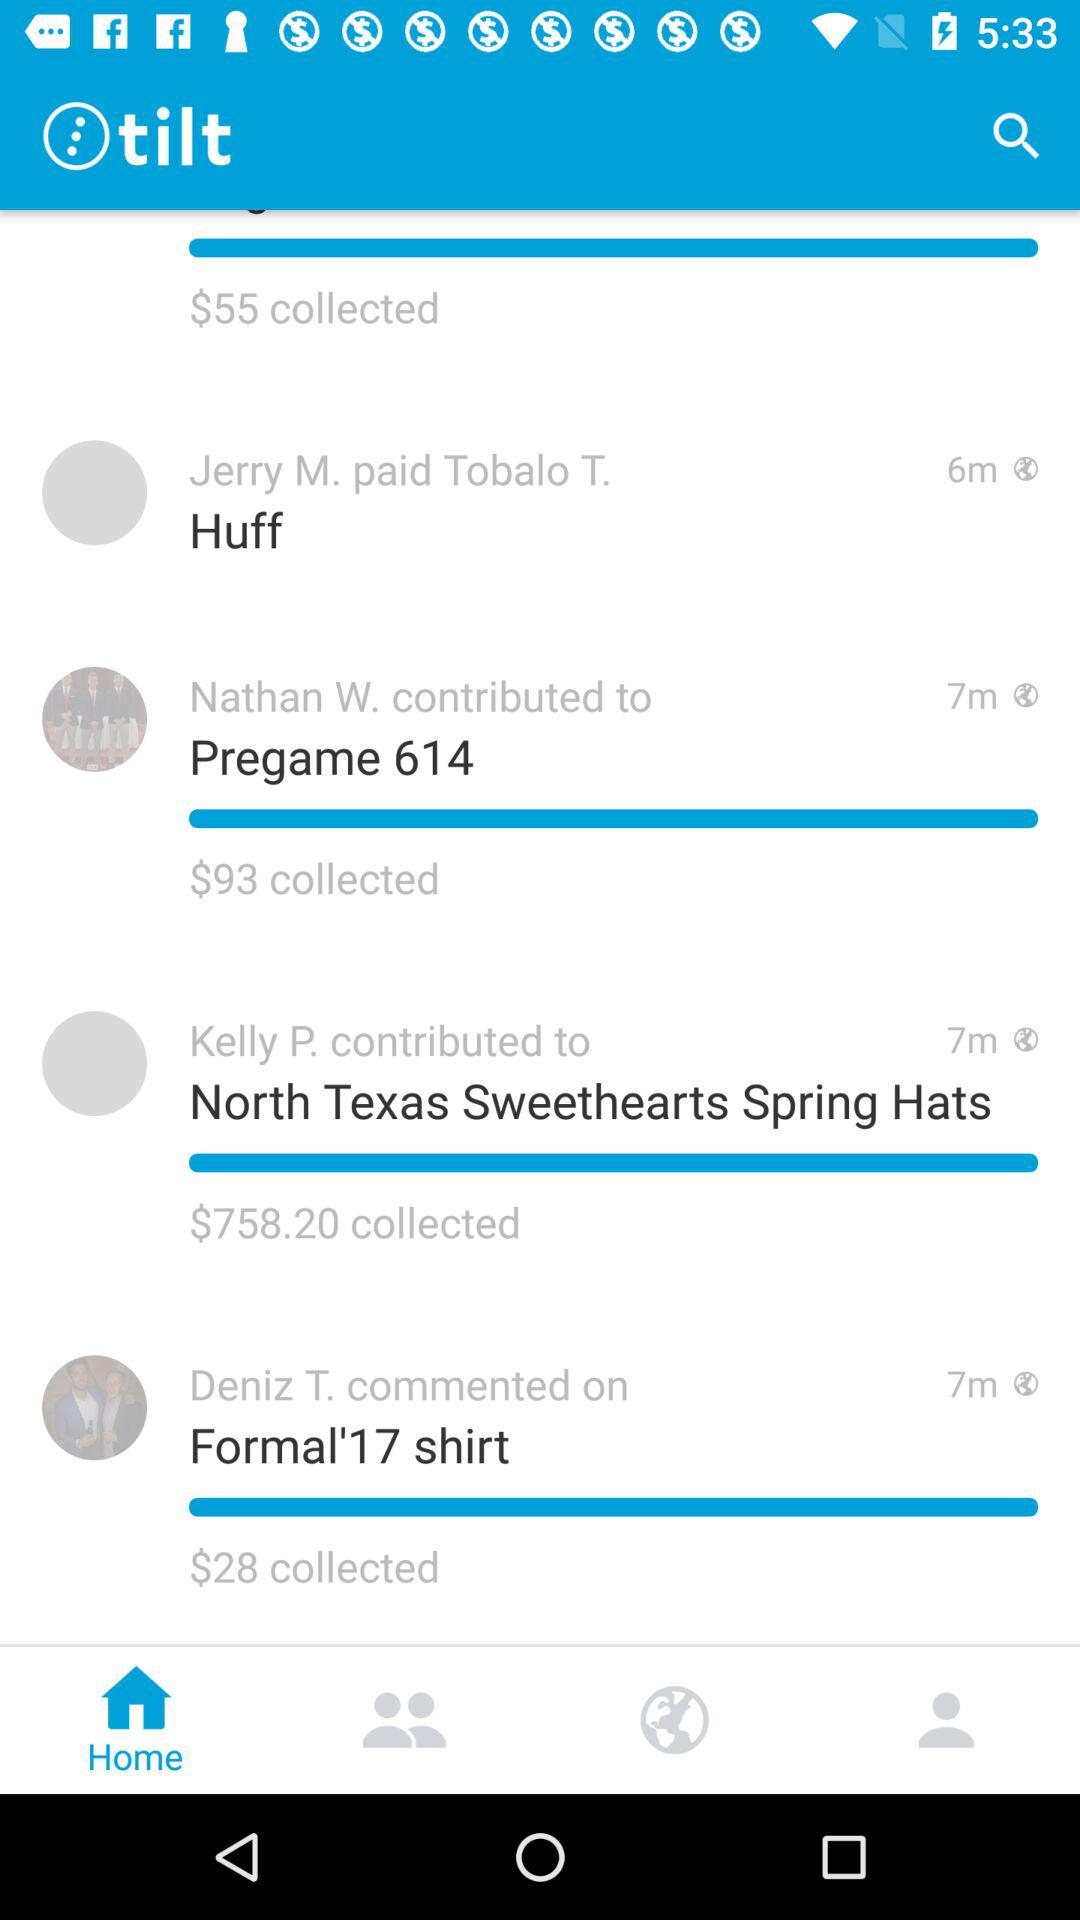How much more money has been collected for the North Texas Sweethearts Spring Hats than the Formal'17 shirt?
Answer the question using a single word or phrase. $730.20 